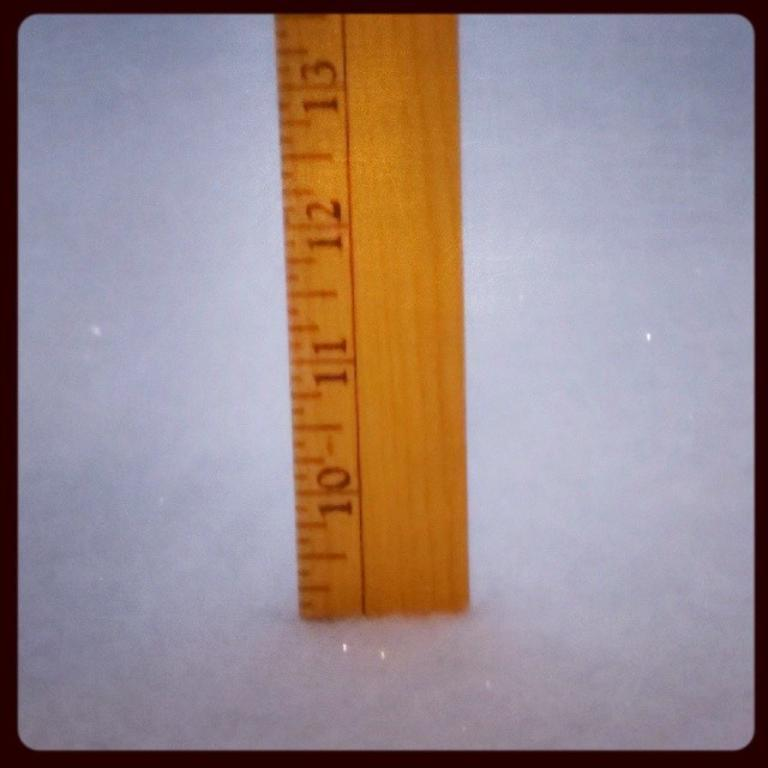Provide a one-sentence caption for the provided image. A ruler sitting in a snowbank with the snow up to the 9 inch level. 